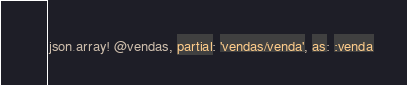<code> <loc_0><loc_0><loc_500><loc_500><_Ruby_>json.array! @vendas, partial: 'vendas/venda', as: :venda
</code> 